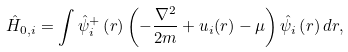<formula> <loc_0><loc_0><loc_500><loc_500>\hat { H } _ { 0 , i } = \int \hat { \psi } _ { i } ^ { + } \left ( r \right ) \left ( - \frac { \nabla ^ { 2 } } { 2 m } + u _ { i } ( r ) - \mu \right ) \hat { \psi } _ { i } \left ( r \right ) d r ,</formula> 